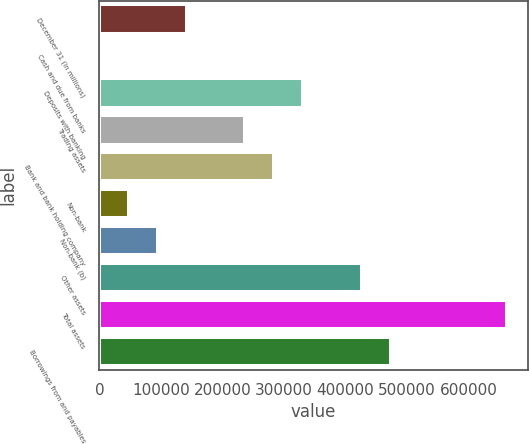<chart> <loc_0><loc_0><loc_500><loc_500><bar_chart><fcel>December 31 (in millions)<fcel>Cash and due from banks<fcel>Deposits with banking<fcel>Trading assets<fcel>Bank and bank holding company<fcel>Non-bank<fcel>Non-bank (b)<fcel>Other assets<fcel>Total assets<fcel>Borrowings from and payables<nl><fcel>142018<fcel>55<fcel>331302<fcel>236660<fcel>283981<fcel>47376<fcel>94697<fcel>425944<fcel>662549<fcel>473265<nl></chart> 